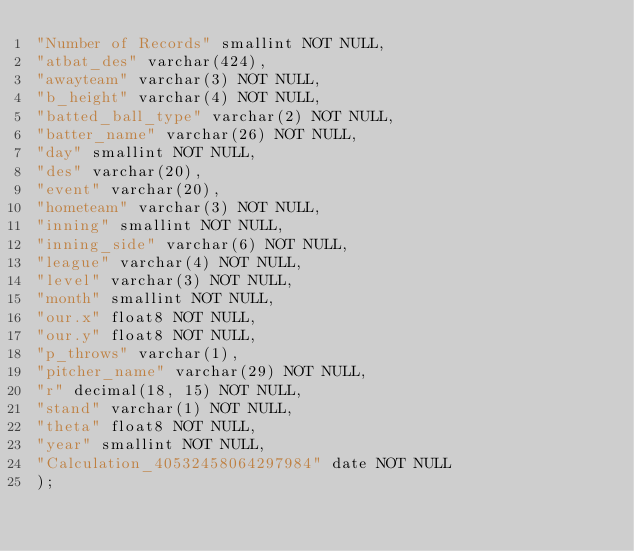<code> <loc_0><loc_0><loc_500><loc_500><_SQL_>"Number of Records" smallint NOT NULL,
"atbat_des" varchar(424),
"awayteam" varchar(3) NOT NULL,
"b_height" varchar(4) NOT NULL,
"batted_ball_type" varchar(2) NOT NULL,
"batter_name" varchar(26) NOT NULL,
"day" smallint NOT NULL,
"des" varchar(20),
"event" varchar(20),
"hometeam" varchar(3) NOT NULL,
"inning" smallint NOT NULL,
"inning_side" varchar(6) NOT NULL,
"league" varchar(4) NOT NULL,
"level" varchar(3) NOT NULL,
"month" smallint NOT NULL,
"our.x" float8 NOT NULL,
"our.y" float8 NOT NULL,
"p_throws" varchar(1),
"pitcher_name" varchar(29) NOT NULL,
"r" decimal(18, 15) NOT NULL,
"stand" varchar(1) NOT NULL,
"theta" float8 NOT NULL,
"year" smallint NOT NULL,
"Calculation_40532458064297984" date NOT NULL
);
</code> 